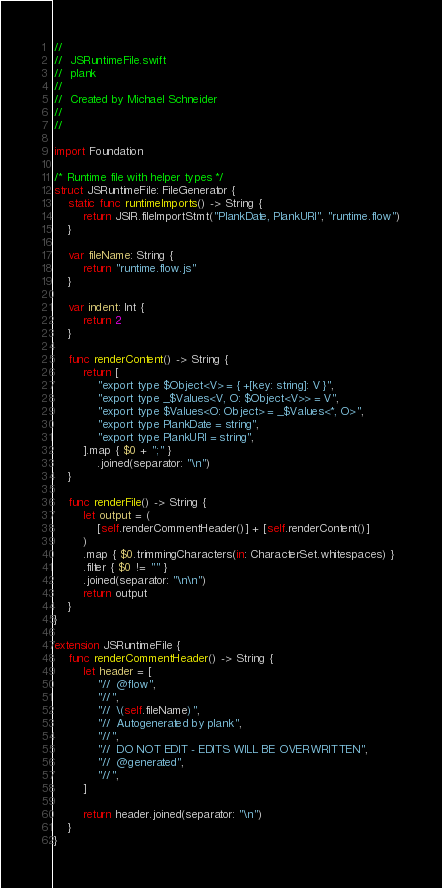<code> <loc_0><loc_0><loc_500><loc_500><_Swift_>//
//  JSRuntimeFile.swift
//  plank
//
//  Created by Michael Schneider
//
//

import Foundation

/* Runtime file with helper types */
struct JSRuntimeFile: FileGenerator {
    static func runtimeImports() -> String {
        return JSIR.fileImportStmt("PlankDate, PlankURI", "runtime.flow")
    }

    var fileName: String {
        return "runtime.flow.js"
    }

    var indent: Int {
        return 2
    }

    func renderContent() -> String {
        return [
            "export type $Object<V> = { +[key: string]: V }",
            "export type _$Values<V, O: $Object<V>> = V",
            "export type $Values<O: Object> = _$Values<*, O>",
            "export type PlankDate = string",
            "export type PlankURI = string",
        ].map { $0 + ";" }
            .joined(separator: "\n")
    }

    func renderFile() -> String {
        let output = (
            [self.renderCommentHeader()] + [self.renderContent()]
        )
        .map { $0.trimmingCharacters(in: CharacterSet.whitespaces) }
        .filter { $0 != "" }
        .joined(separator: "\n\n")
        return output
    }
}

extension JSRuntimeFile {
    func renderCommentHeader() -> String {
        let header = [
            "//  @flow",
            "//",
            "//  \(self.fileName)",
            "//  Autogenerated by plank",
            "//",
            "//  DO NOT EDIT - EDITS WILL BE OVERWRITTEN",
            "//  @generated",
            "//",
        ]

        return header.joined(separator: "\n")
    }
}
</code> 